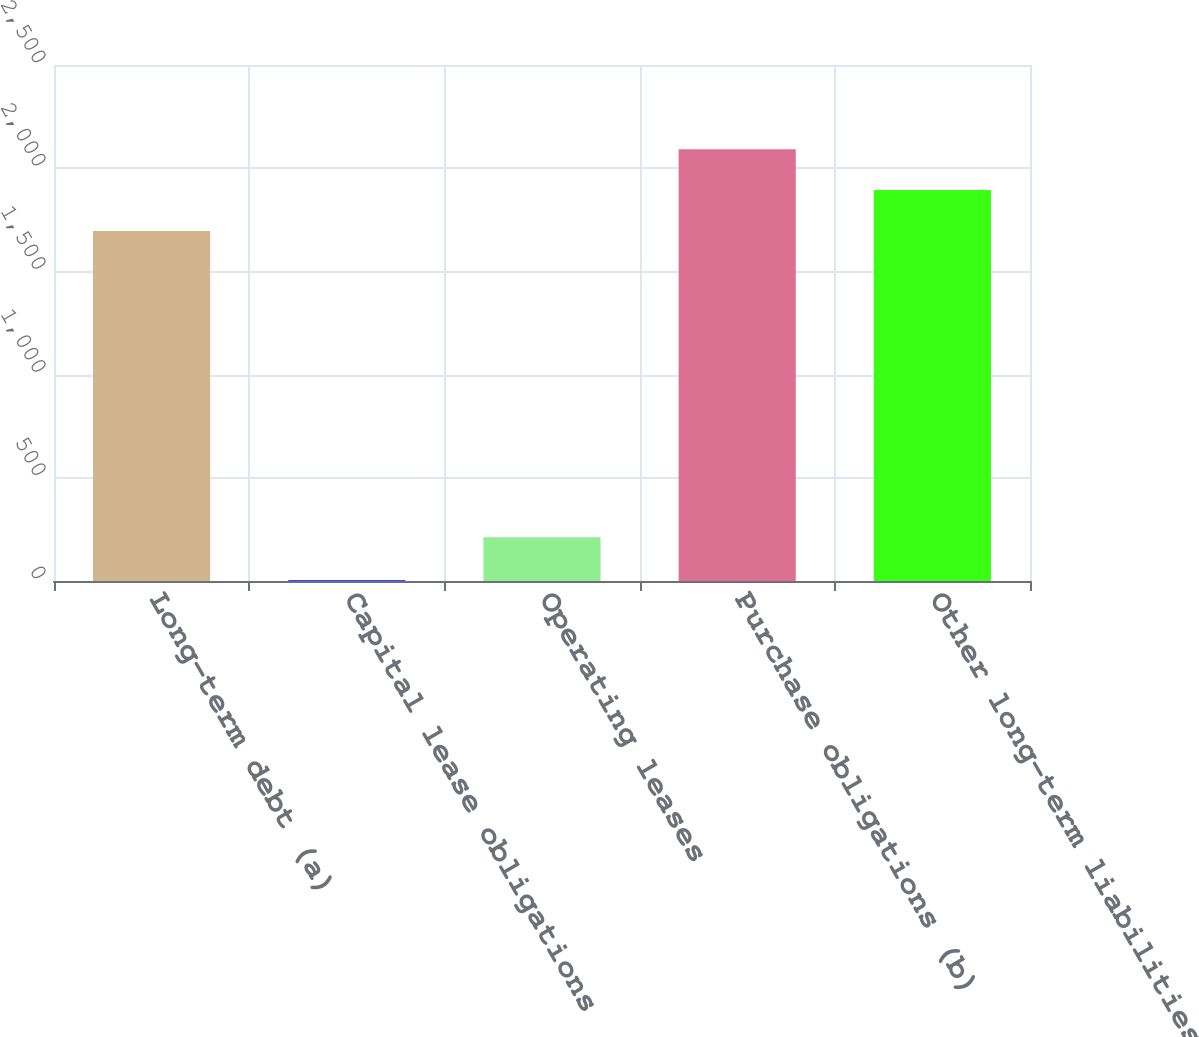<chart> <loc_0><loc_0><loc_500><loc_500><bar_chart><fcel>Long-term debt (a)<fcel>Capital lease obligations<fcel>Operating leases<fcel>Purchase obligations (b)<fcel>Other long-term liabilities<nl><fcel>1696<fcel>4<fcel>212<fcel>2091.8<fcel>1893.9<nl></chart> 